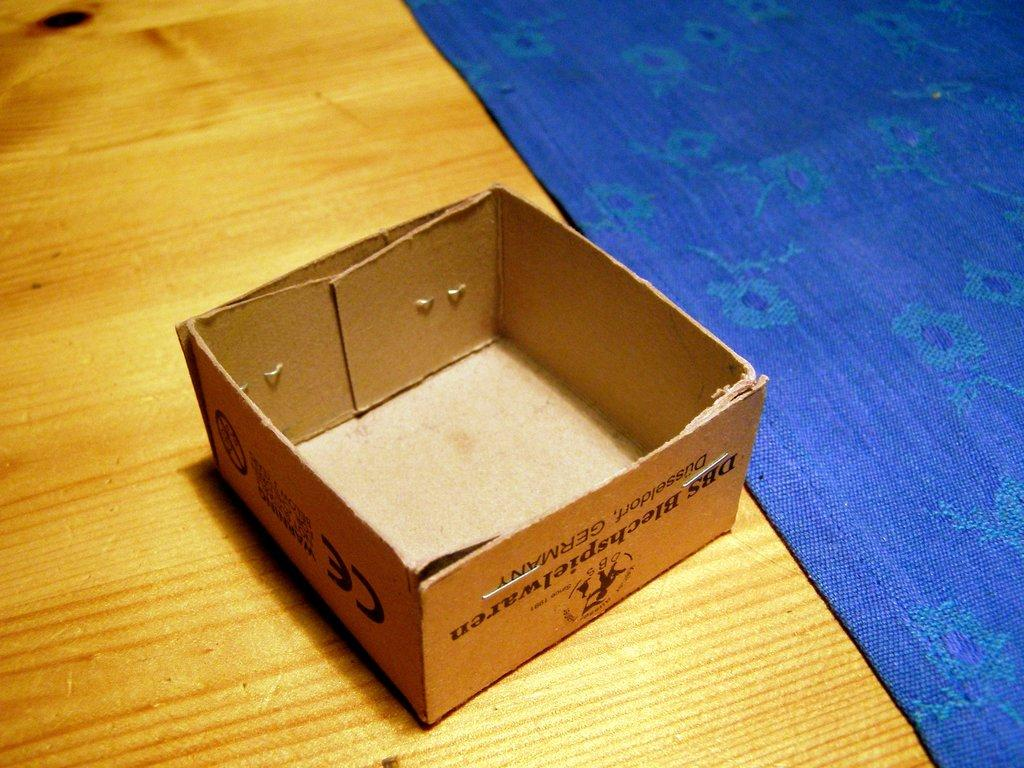<image>
Present a compact description of the photo's key features. a cardboard box without a top that says ce on the side of it 